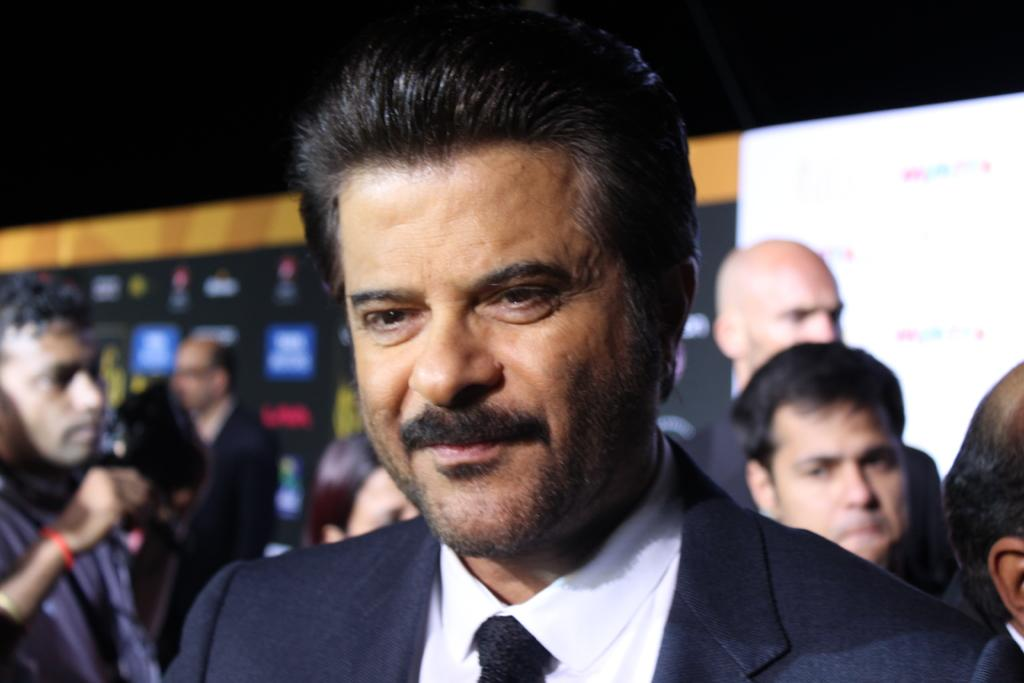What is happening with the people in the image? There are people standing in the image. Can you describe the facial expression of one of the individuals? A man is smiling in the image. What is the man wearing in the image? The man is wearing a black coat and a black tie. What can be seen in the background of the image? There are advertisement hoardings visible in the background of the image. What type of glass is the man holding in the image? There is no glass present in the image; the man is not holding anything. 